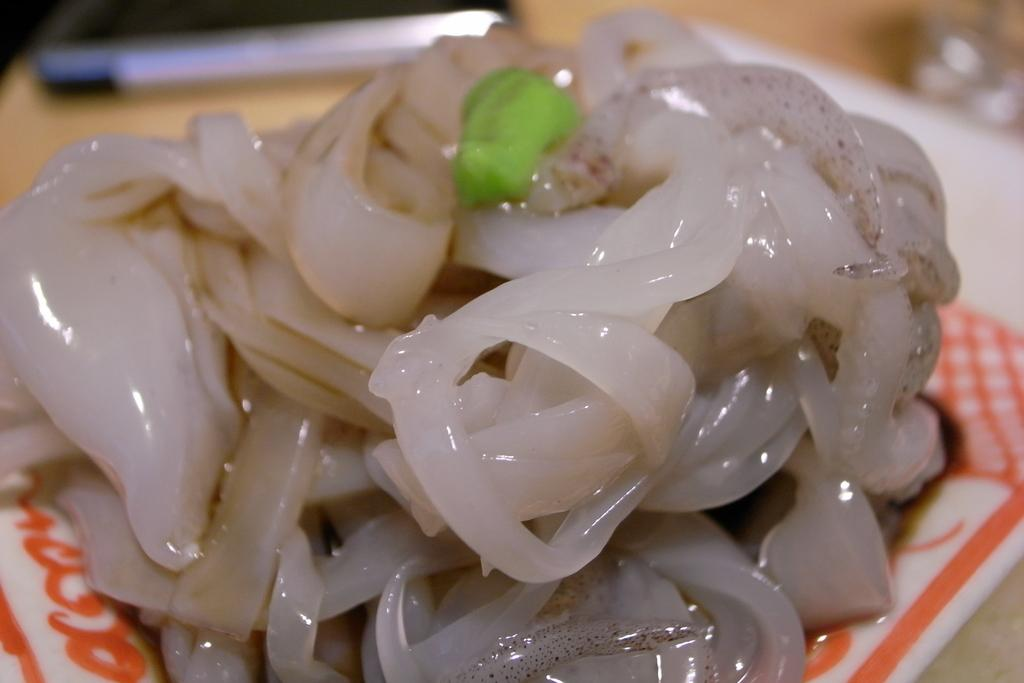What is on the plate that is visible in the image? There is food present in a plate. Can you describe the background of the image? The background of the image is blurry. What type of twist can be seen in the image? There is no twist present in the image. Are there any feathers visible in the image? There are no feathers present in the image. 